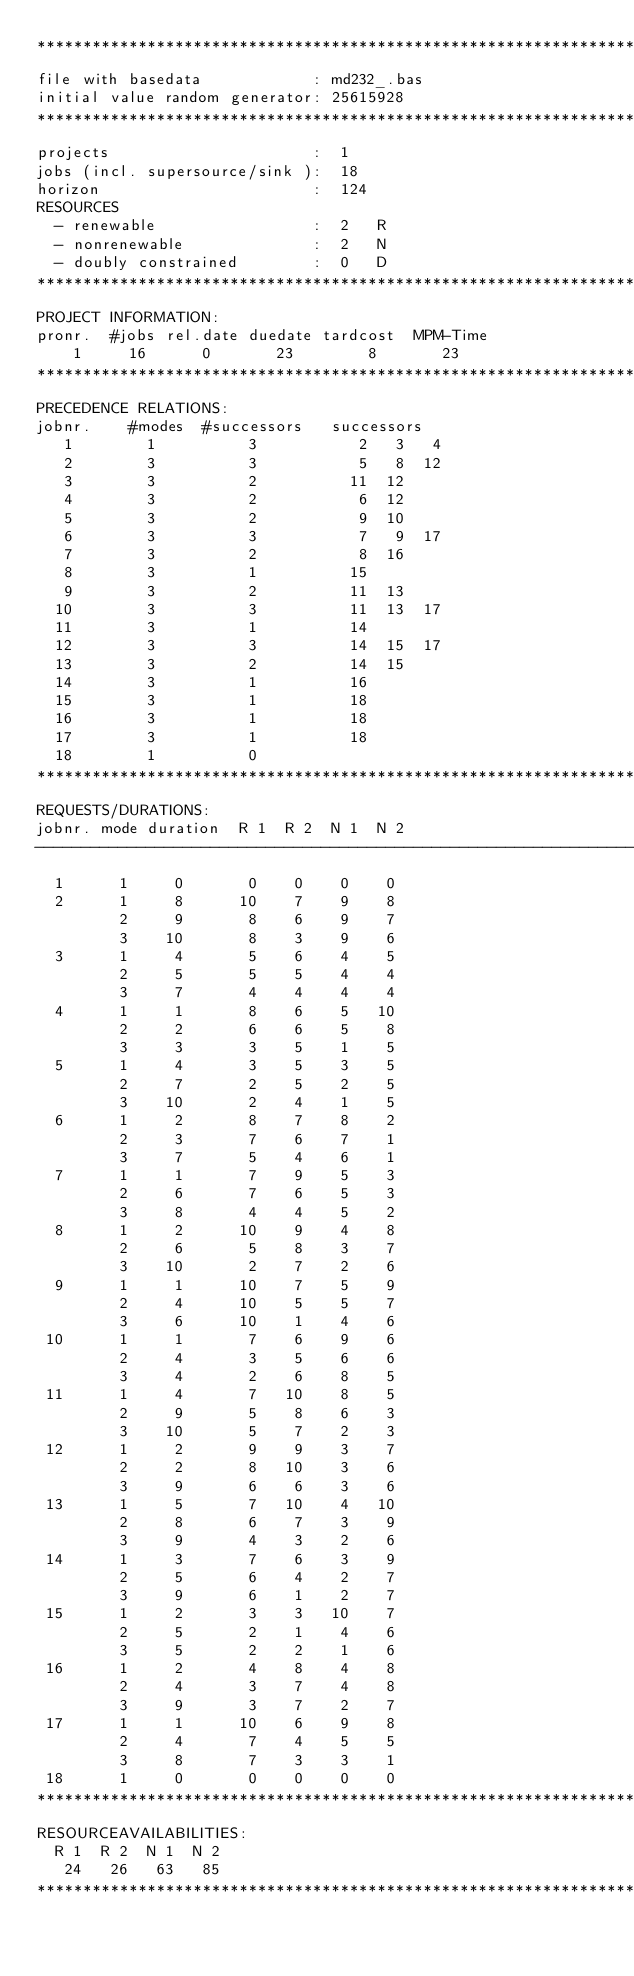Convert code to text. <code><loc_0><loc_0><loc_500><loc_500><_ObjectiveC_>************************************************************************
file with basedata            : md232_.bas
initial value random generator: 25615928
************************************************************************
projects                      :  1
jobs (incl. supersource/sink ):  18
horizon                       :  124
RESOURCES
  - renewable                 :  2   R
  - nonrenewable              :  2   N
  - doubly constrained        :  0   D
************************************************************************
PROJECT INFORMATION:
pronr.  #jobs rel.date duedate tardcost  MPM-Time
    1     16      0       23        8       23
************************************************************************
PRECEDENCE RELATIONS:
jobnr.    #modes  #successors   successors
   1        1          3           2   3   4
   2        3          3           5   8  12
   3        3          2          11  12
   4        3          2           6  12
   5        3          2           9  10
   6        3          3           7   9  17
   7        3          2           8  16
   8        3          1          15
   9        3          2          11  13
  10        3          3          11  13  17
  11        3          1          14
  12        3          3          14  15  17
  13        3          2          14  15
  14        3          1          16
  15        3          1          18
  16        3          1          18
  17        3          1          18
  18        1          0        
************************************************************************
REQUESTS/DURATIONS:
jobnr. mode duration  R 1  R 2  N 1  N 2
------------------------------------------------------------------------
  1      1     0       0    0    0    0
  2      1     8      10    7    9    8
         2     9       8    6    9    7
         3    10       8    3    9    6
  3      1     4       5    6    4    5
         2     5       5    5    4    4
         3     7       4    4    4    4
  4      1     1       8    6    5   10
         2     2       6    6    5    8
         3     3       3    5    1    5
  5      1     4       3    5    3    5
         2     7       2    5    2    5
         3    10       2    4    1    5
  6      1     2       8    7    8    2
         2     3       7    6    7    1
         3     7       5    4    6    1
  7      1     1       7    9    5    3
         2     6       7    6    5    3
         3     8       4    4    5    2
  8      1     2      10    9    4    8
         2     6       5    8    3    7
         3    10       2    7    2    6
  9      1     1      10    7    5    9
         2     4      10    5    5    7
         3     6      10    1    4    6
 10      1     1       7    6    9    6
         2     4       3    5    6    6
         3     4       2    6    8    5
 11      1     4       7   10    8    5
         2     9       5    8    6    3
         3    10       5    7    2    3
 12      1     2       9    9    3    7
         2     2       8   10    3    6
         3     9       6    6    3    6
 13      1     5       7   10    4   10
         2     8       6    7    3    9
         3     9       4    3    2    6
 14      1     3       7    6    3    9
         2     5       6    4    2    7
         3     9       6    1    2    7
 15      1     2       3    3   10    7
         2     5       2    1    4    6
         3     5       2    2    1    6
 16      1     2       4    8    4    8
         2     4       3    7    4    8
         3     9       3    7    2    7
 17      1     1      10    6    9    8
         2     4       7    4    5    5
         3     8       7    3    3    1
 18      1     0       0    0    0    0
************************************************************************
RESOURCEAVAILABILITIES:
  R 1  R 2  N 1  N 2
   24   26   63   85
************************************************************************
</code> 